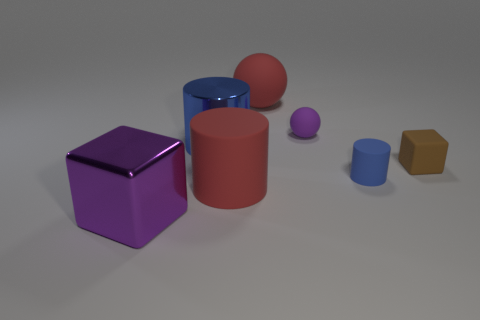If we were to use these shapes to teach a lesson about shadows, what observations could we discuss? Using these shapes to teach about shadows would be very insightful. We could observe how the direction and angle of light affect the length and orientation of the shadows cast by each object. Discussions could include how the round shapes, like the spheres, cast softer-edged shadows compared to the sharper-edged shadows of the cube and hexagonal prism. This exercise can demonstrate the concept of light traveling in straight lines and how it interacts with different surfaces to create varying types of shadows. 